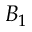<formula> <loc_0><loc_0><loc_500><loc_500>B _ { 1 }</formula> 